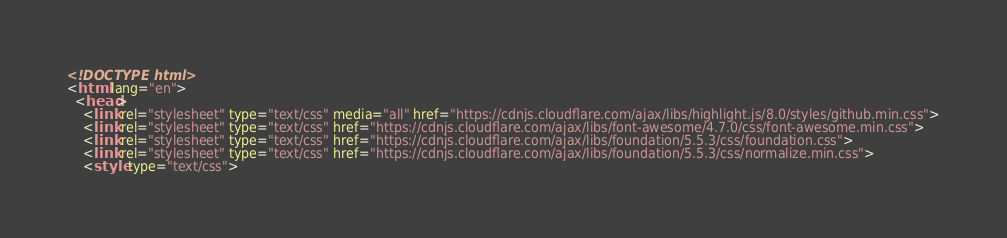Convert code to text. <code><loc_0><loc_0><loc_500><loc_500><_HTML_><!DOCTYPE html>
<html lang="en">
  <head>
    <link rel="stylesheet" type="text/css" media="all" href="https://cdnjs.cloudflare.com/ajax/libs/highlight.js/8.0/styles/github.min.css">
    <link rel="stylesheet" type="text/css" href="https://cdnjs.cloudflare.com/ajax/libs/font-awesome/4.7.0/css/font-awesome.min.css">
    <link rel="stylesheet" type="text/css" href="https://cdnjs.cloudflare.com/ajax/libs/foundation/5.5.3/css/foundation.css">
    <link rel="stylesheet" type="text/css" href="https://cdnjs.cloudflare.com/ajax/libs/foundation/5.5.3/css/normalize.min.css">
    <style type="text/css"></code> 